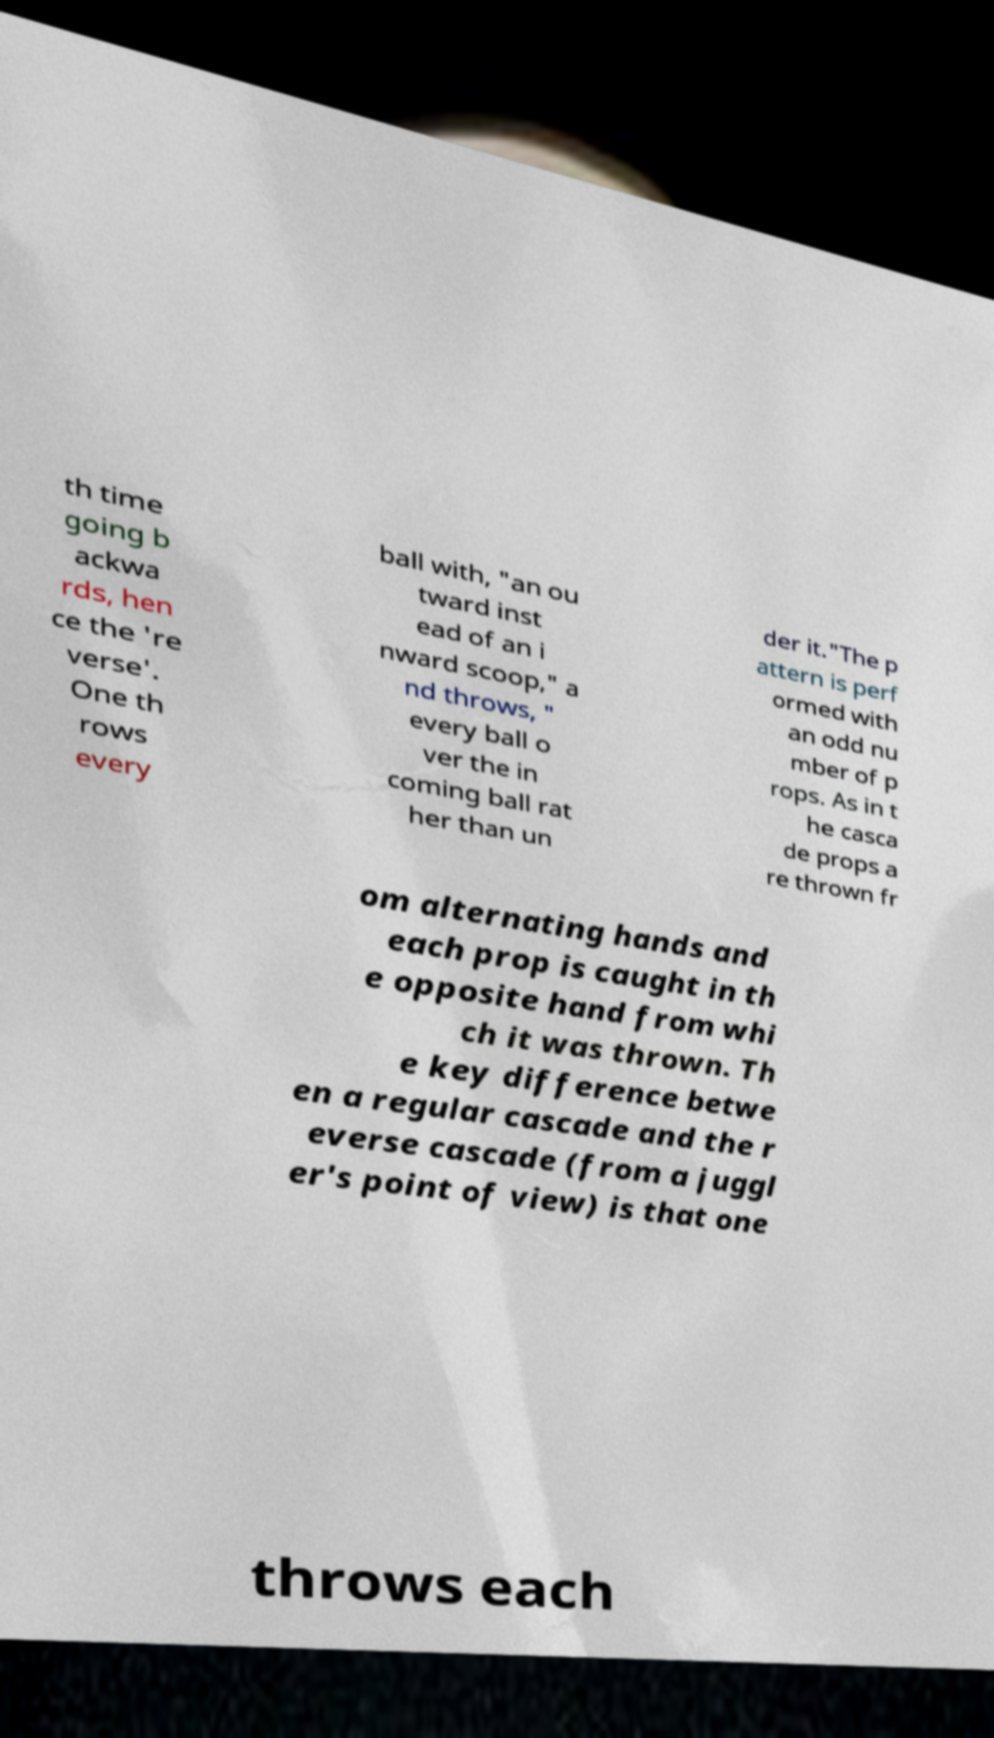Could you assist in decoding the text presented in this image and type it out clearly? th time going b ackwa rds, hen ce the 're verse'. One th rows every ball with, "an ou tward inst ead of an i nward scoop," a nd throws, " every ball o ver the in coming ball rat her than un der it."The p attern is perf ormed with an odd nu mber of p rops. As in t he casca de props a re thrown fr om alternating hands and each prop is caught in th e opposite hand from whi ch it was thrown. Th e key difference betwe en a regular cascade and the r everse cascade (from a juggl er's point of view) is that one throws each 